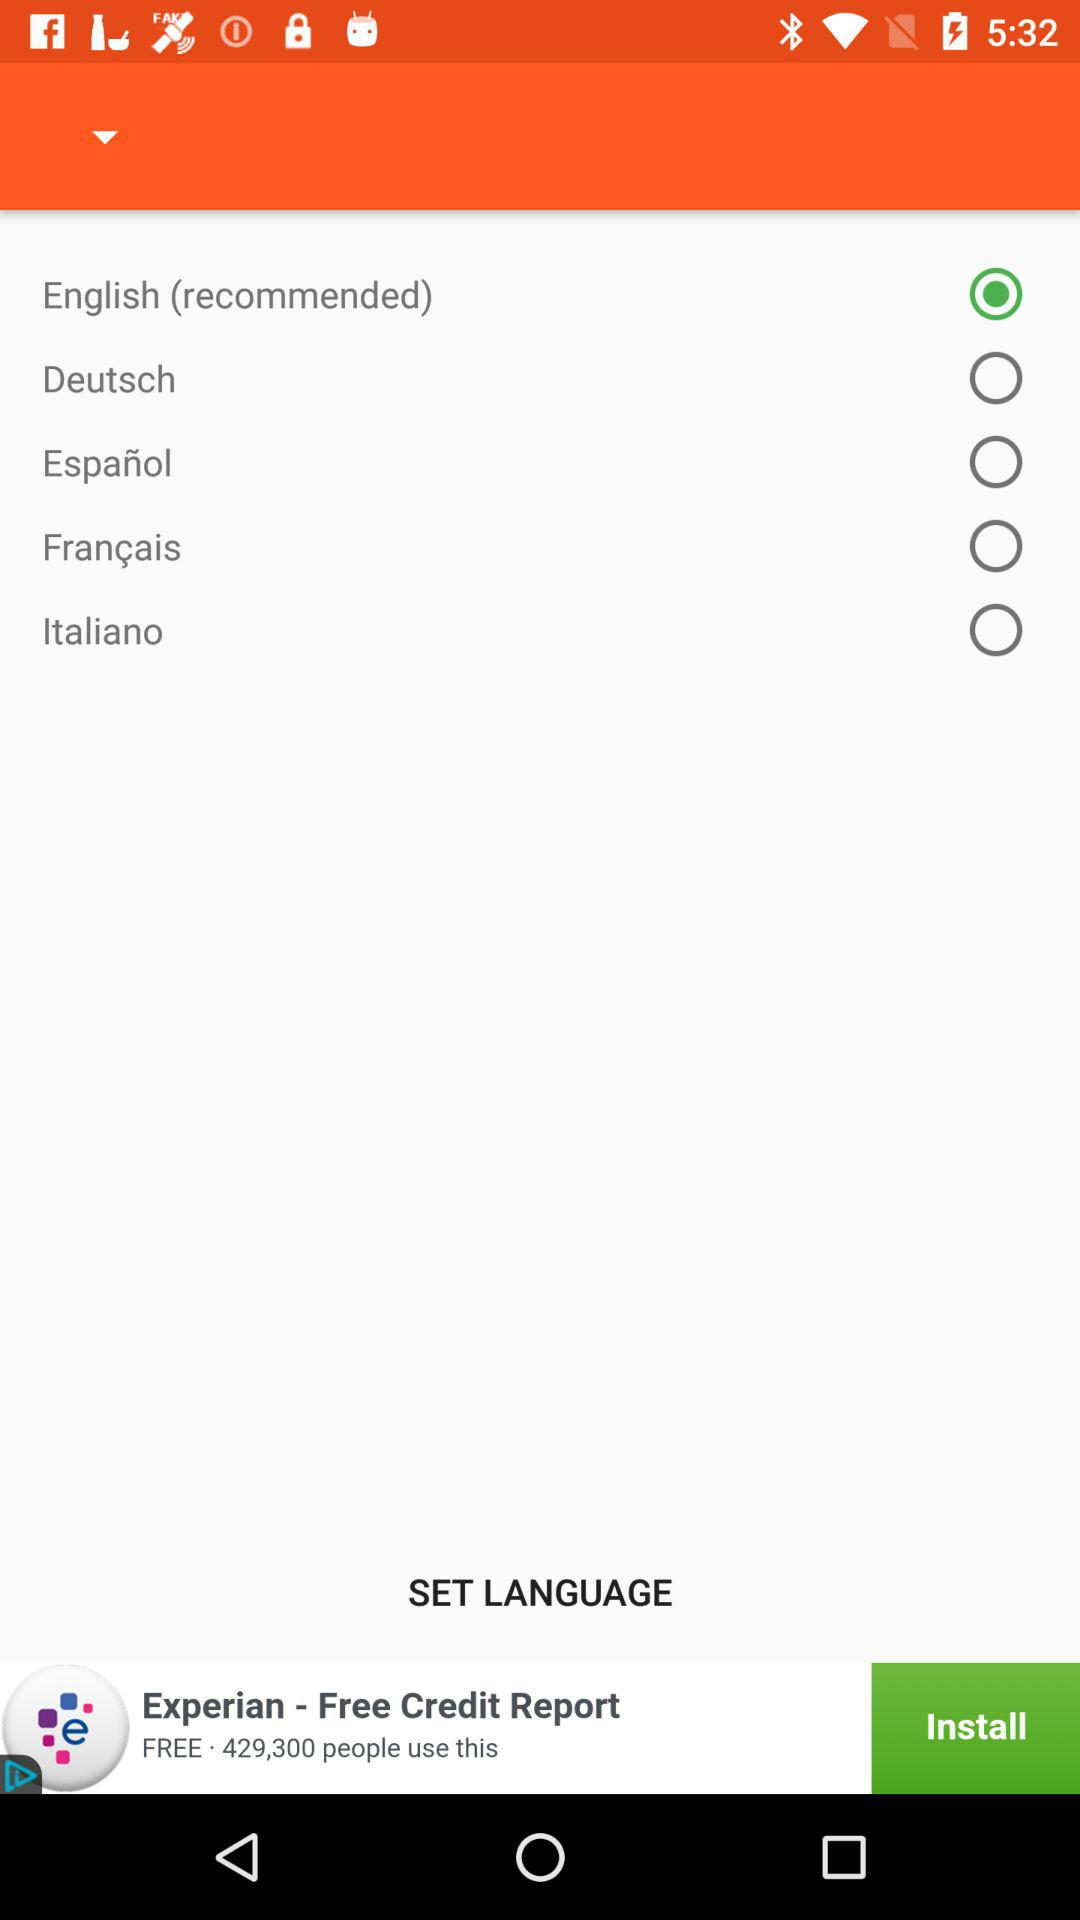How many languages are available to choose from?
Answer the question using a single word or phrase. 5 